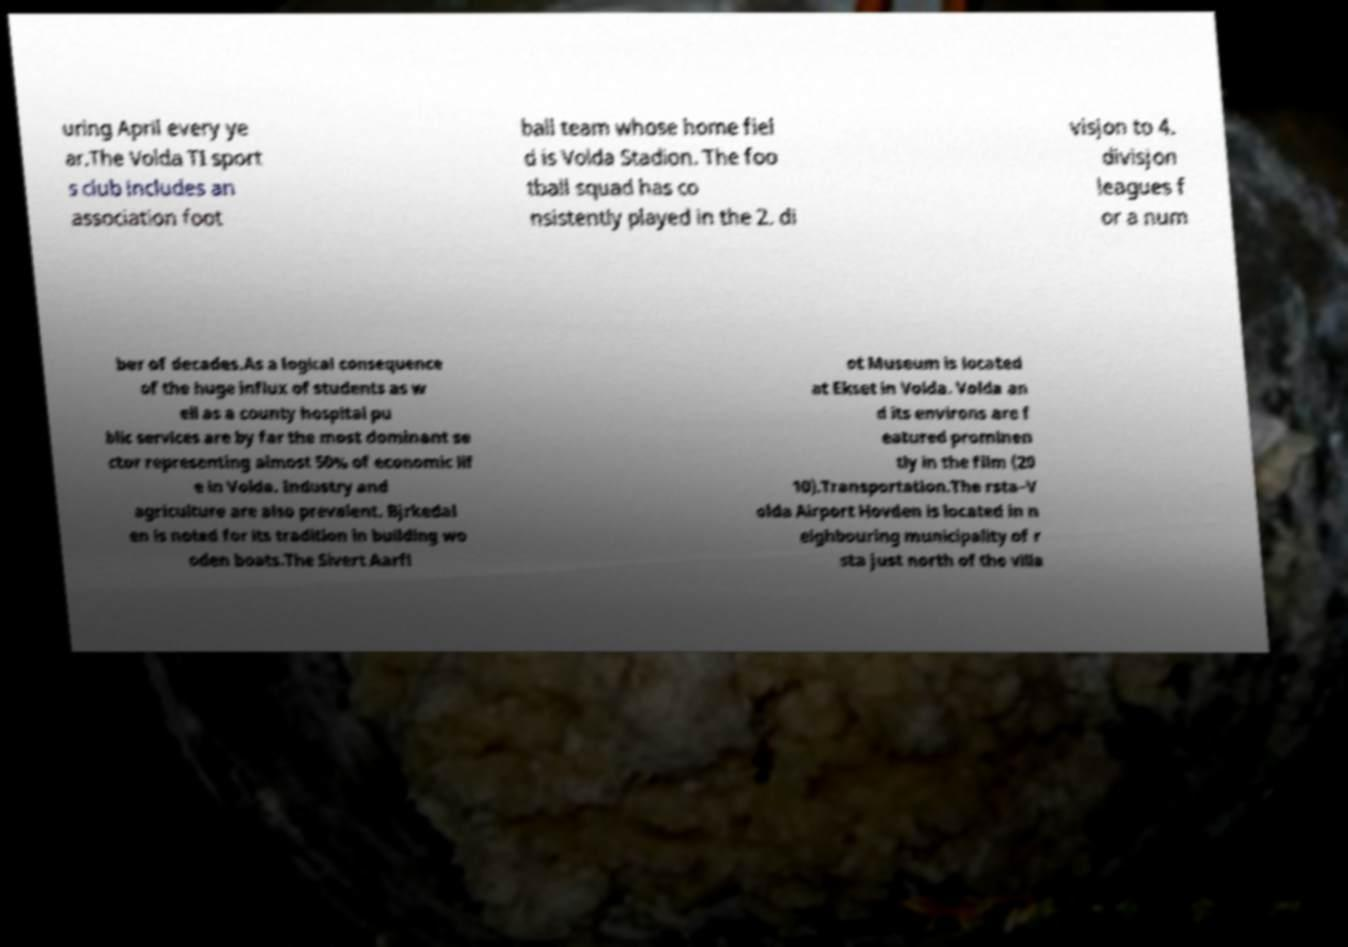There's text embedded in this image that I need extracted. Can you transcribe it verbatim? uring April every ye ar.The Volda TI sport s club includes an association foot ball team whose home fiel d is Volda Stadion. The foo tball squad has co nsistently played in the 2. di visjon to 4. divisjon leagues f or a num ber of decades.As a logical consequence of the huge influx of students as w ell as a county hospital pu blic services are by far the most dominant se ctor representing almost 50% of economic lif e in Volda. Industry and agriculture are also prevalent. Bjrkedal en is noted for its tradition in building wo oden boats.The Sivert Aarfl ot Museum is located at Ekset in Volda. Volda an d its environs are f eatured prominen tly in the film (20 10).Transportation.The rsta–V olda Airport Hovden is located in n eighbouring municipality of r sta just north of the villa 